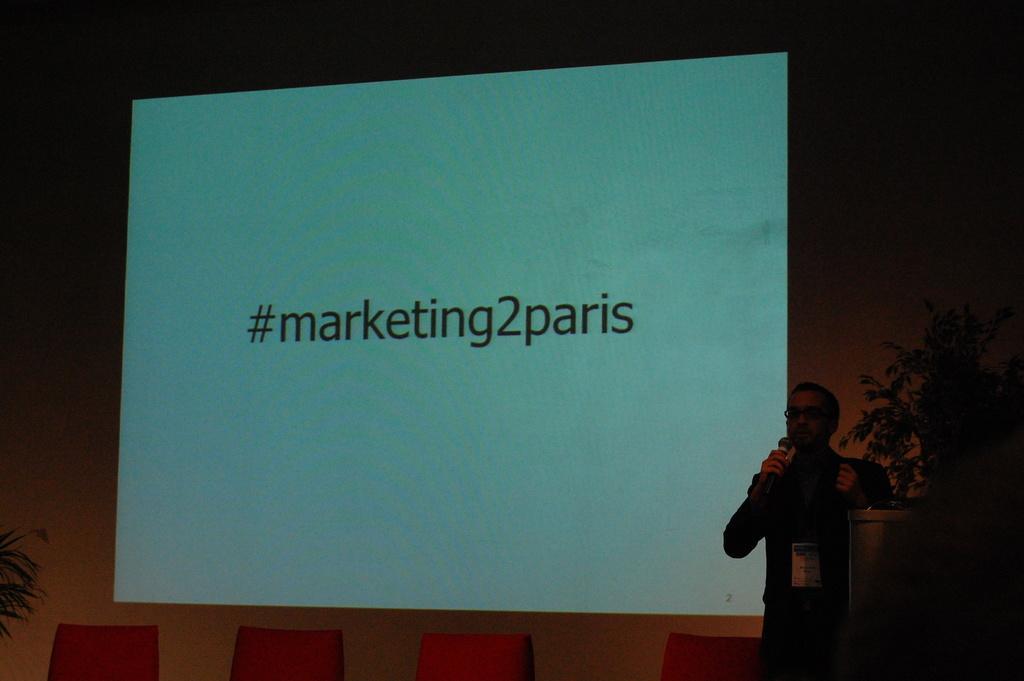How would you summarize this image in a sentence or two? In this image we can see a person standing and holding microphones. And we can see the podium. And we can see the flower pots. And we can see the screen. And we can see the chairs. 